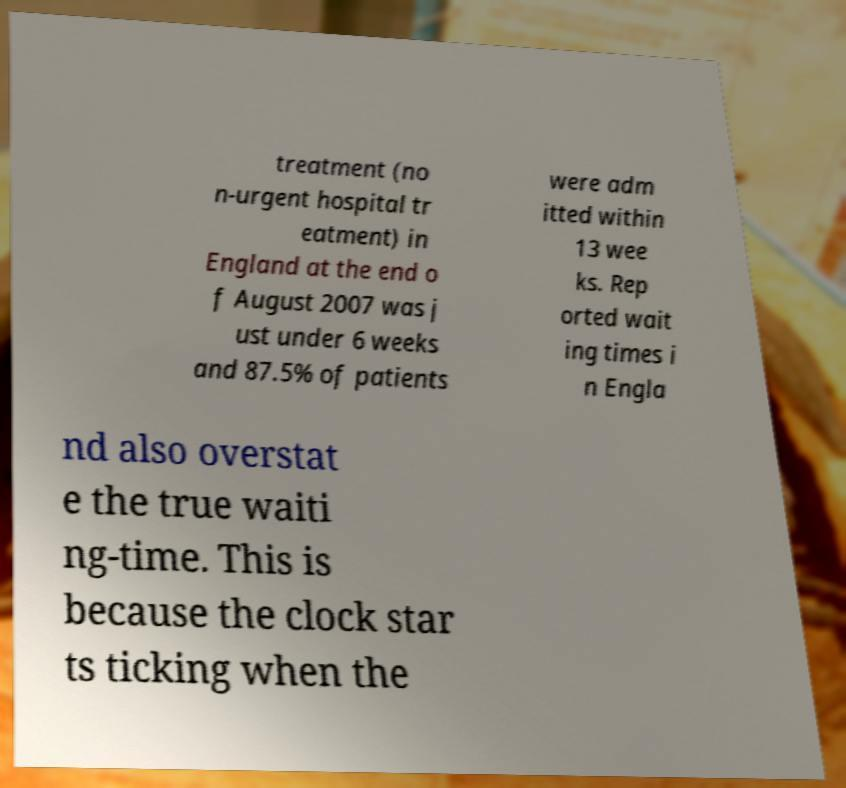Could you assist in decoding the text presented in this image and type it out clearly? treatment (no n-urgent hospital tr eatment) in England at the end o f August 2007 was j ust under 6 weeks and 87.5% of patients were adm itted within 13 wee ks. Rep orted wait ing times i n Engla nd also overstat e the true waiti ng-time. This is because the clock star ts ticking when the 